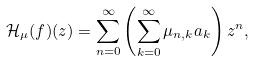<formula> <loc_0><loc_0><loc_500><loc_500>\mathcal { H } _ { \mu } ( f ) ( z ) = \sum _ { n = 0 } ^ { \infty } \left ( \sum _ { k = 0 } ^ { \infty } \mu _ { n , k } { a _ { k } } \right ) z ^ { n } ,</formula> 